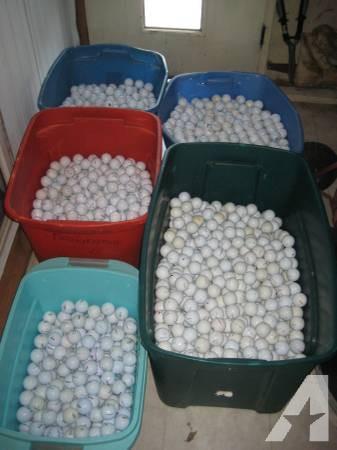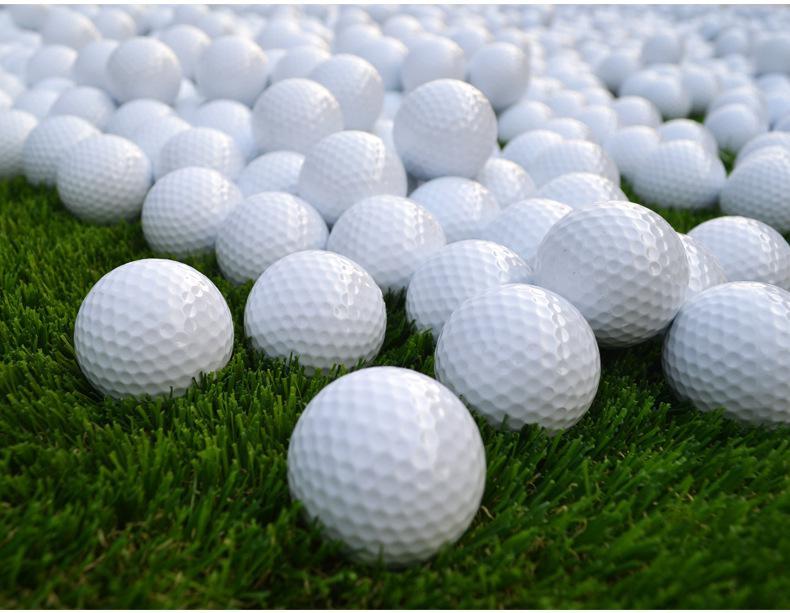The first image is the image on the left, the second image is the image on the right. Assess this claim about the two images: "In at least one image there is a pile of white golf balls and at least one yellow golf ball.". Correct or not? Answer yes or no. No. The first image is the image on the left, the second image is the image on the right. Considering the images on both sides, is "Some of the balls are not white in one image and all the balls are white in the other image." valid? Answer yes or no. No. 